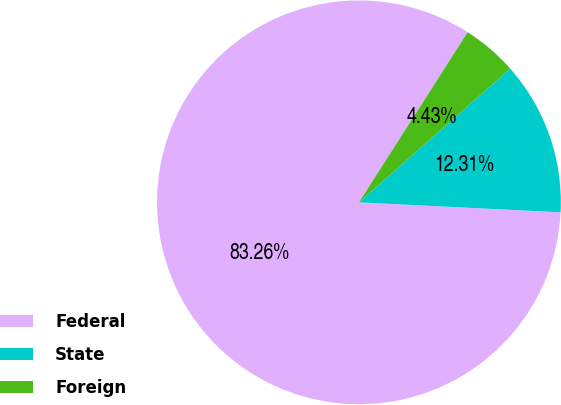Convert chart to OTSL. <chart><loc_0><loc_0><loc_500><loc_500><pie_chart><fcel>Federal<fcel>State<fcel>Foreign<nl><fcel>83.26%<fcel>12.31%<fcel>4.43%<nl></chart> 